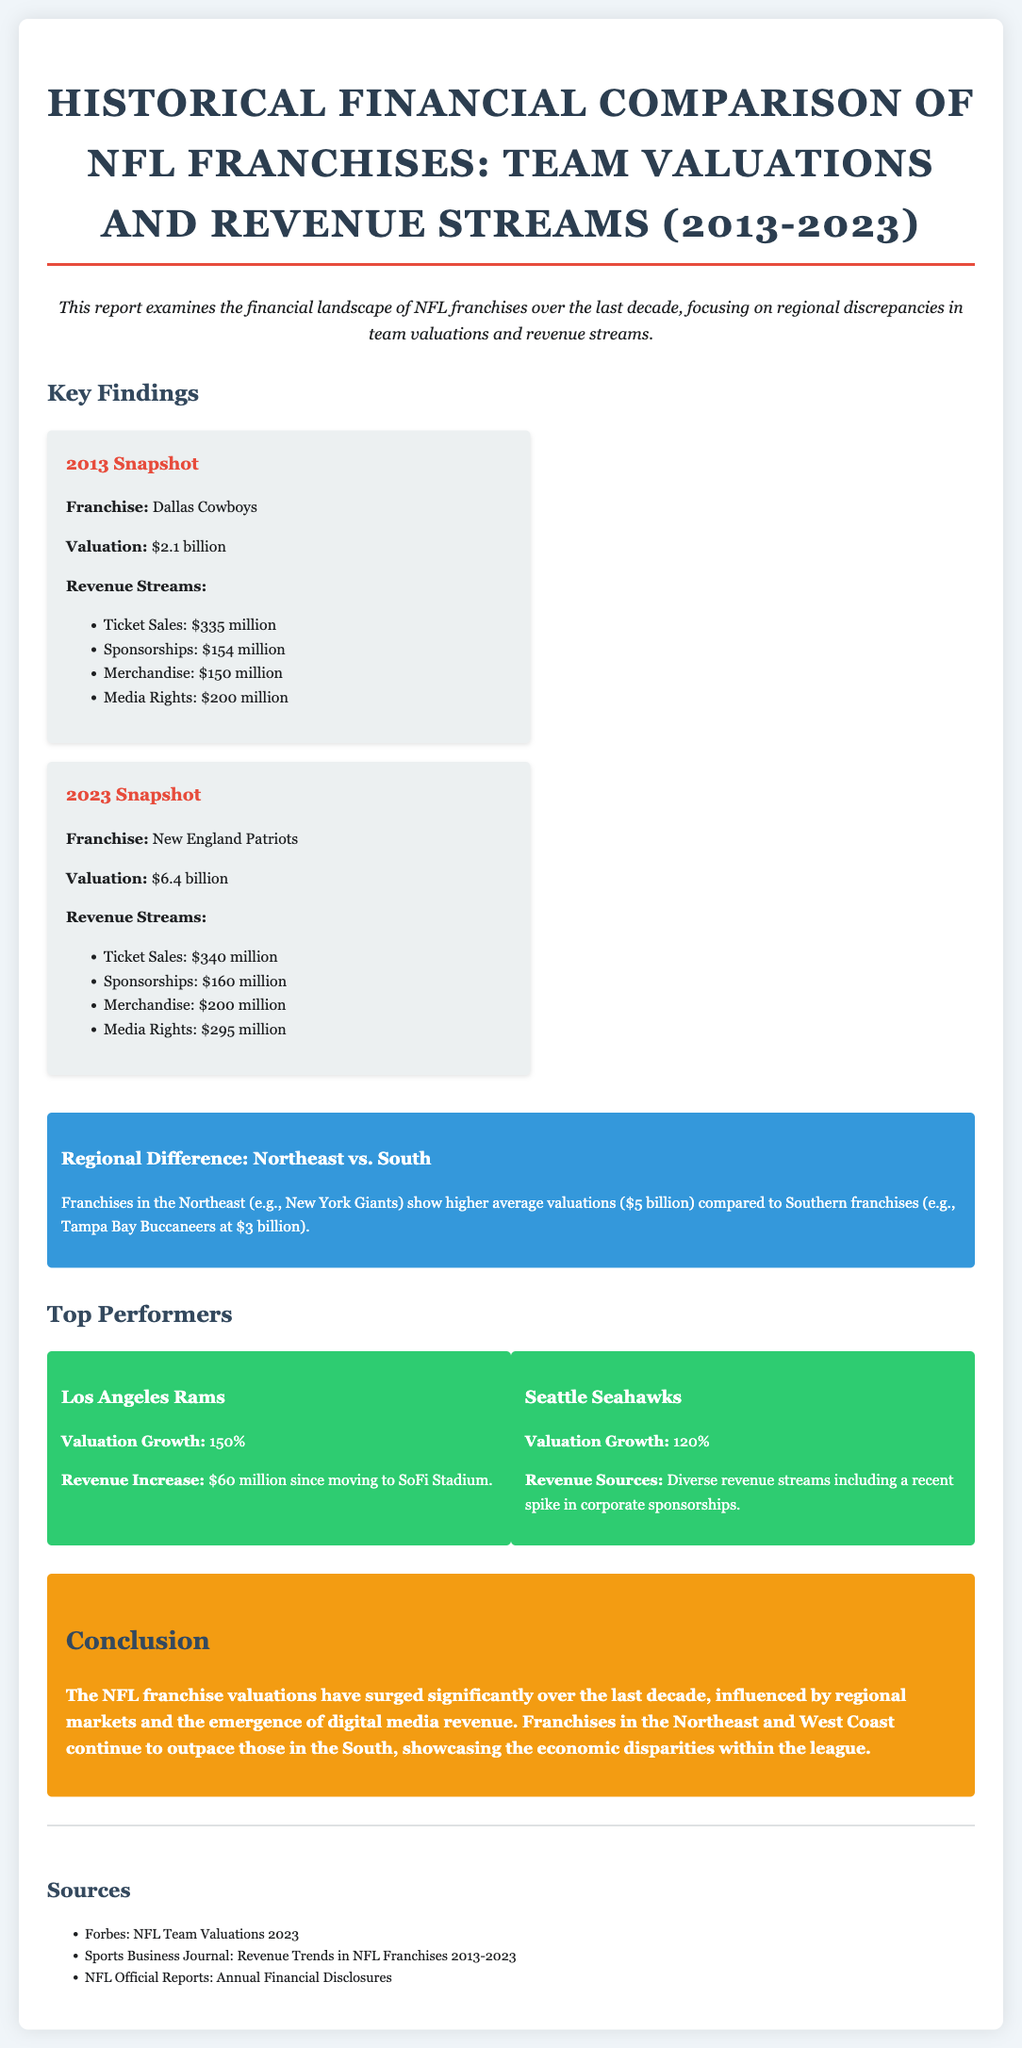what was the valuation of the Dallas Cowboys in 2013? The document states that the valuation of the Dallas Cowboys in 2013 was $2.1 billion.
Answer: $2.1 billion what was the revenue from Media Rights for the New England Patriots in 2023? The document lists the Media Rights revenue for the New England Patriots in 2023 as $295 million.
Answer: $295 million which franchise had a valuation growth of 150%? The document indicates that the Los Angeles Rams had a valuation growth of 150%.
Answer: Los Angeles Rams what is the average valuation of Northeast franchises mentioned in the document? The document reports that Northeast franchises have an average valuation of $5 billion.
Answer: $5 billion which two franchises were noted as top performers? The document highlights the Los Angeles Rams and the Seattle Seahawks as top performers.
Answer: Los Angeles Rams and Seattle Seahawks what is the primary reason for the economic disparities within the NFL according to the document? The document suggests that regional markets and the emergence of digital media revenue influence economic disparities within the NFL.
Answer: Regional markets and digital media revenue how much did the Seattle Seahawks' valuation grow? The document states that the Seattle Seahawks experienced a valuation growth of 120%.
Answer: 120% which southern franchise was mentioned, and what was its valuation? The document references the Tampa Bay Buccaneers with a valuation of $3 billion.
Answer: Tampa Bay Buccaneers at $3 billion 